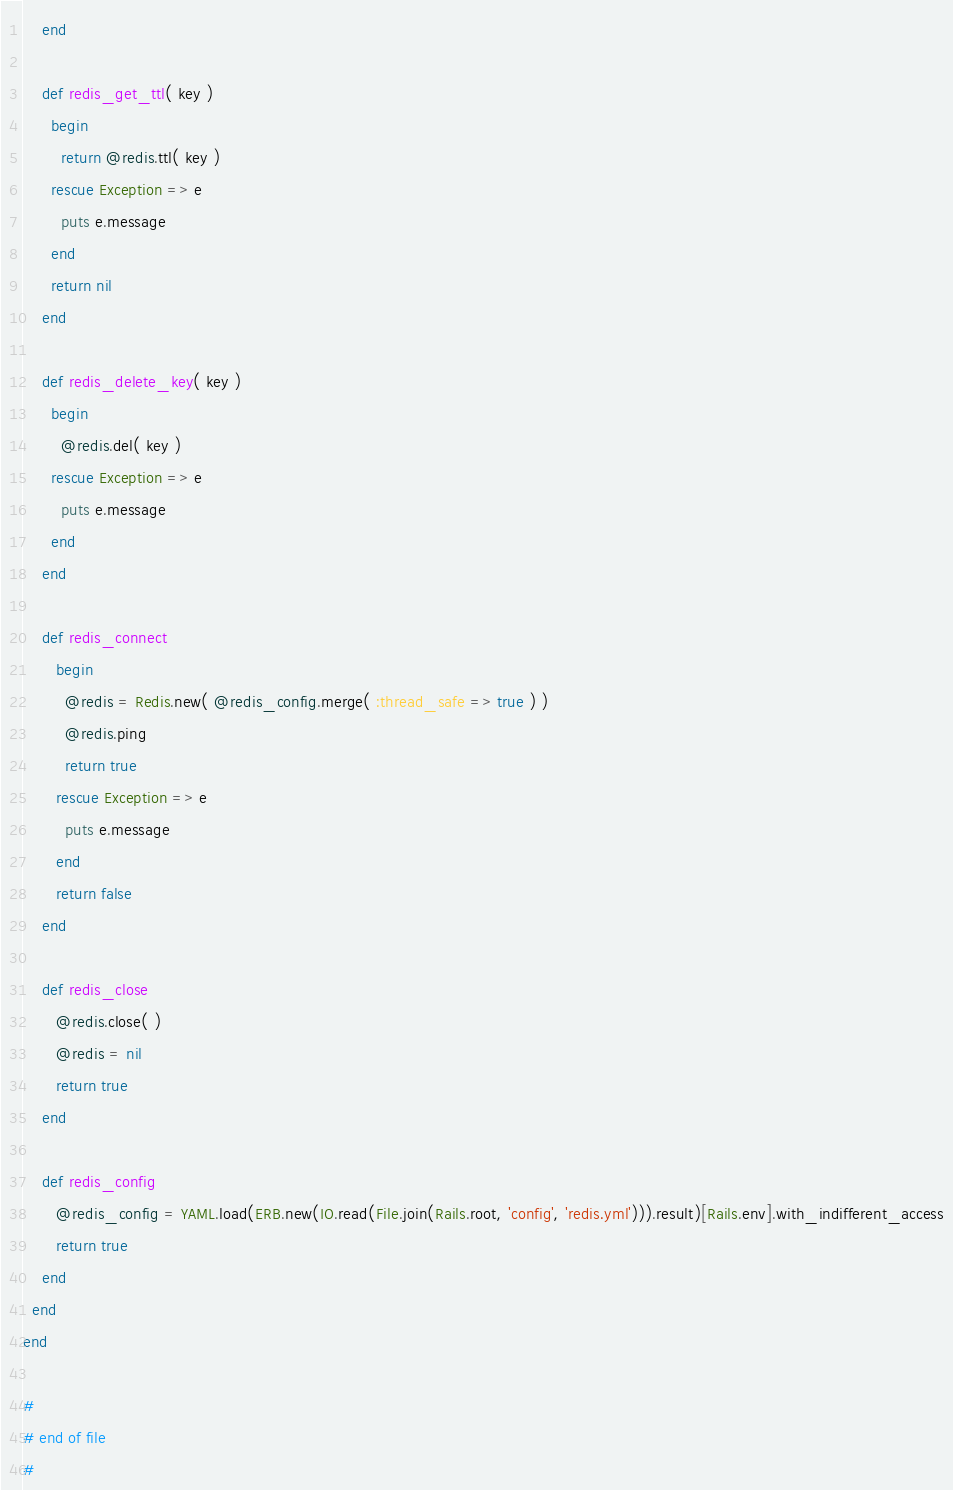Convert code to text. <code><loc_0><loc_0><loc_500><loc_500><_Ruby_>    end

    def redis_get_ttl( key )
      begin
        return @redis.ttl( key )
      rescue Exception => e
        puts e.message
      end
      return nil
    end

    def redis_delete_key( key )
      begin
        @redis.del( key )
      rescue Exception => e
        puts e.message
      end
    end

    def redis_connect
       begin
         @redis = Redis.new( @redis_config.merge( :thread_safe => true ) )
         @redis.ping
         return true
       rescue Exception => e
         puts e.message
       end
       return false
    end

    def redis_close
       @redis.close( )
       @redis = nil
       return true
    end

    def redis_config
       @redis_config = YAML.load(ERB.new(IO.read(File.join(Rails.root, 'config', 'redis.yml'))).result)[Rails.env].with_indifferent_access
       return true
    end
  end
end

#
# end of file
#</code> 